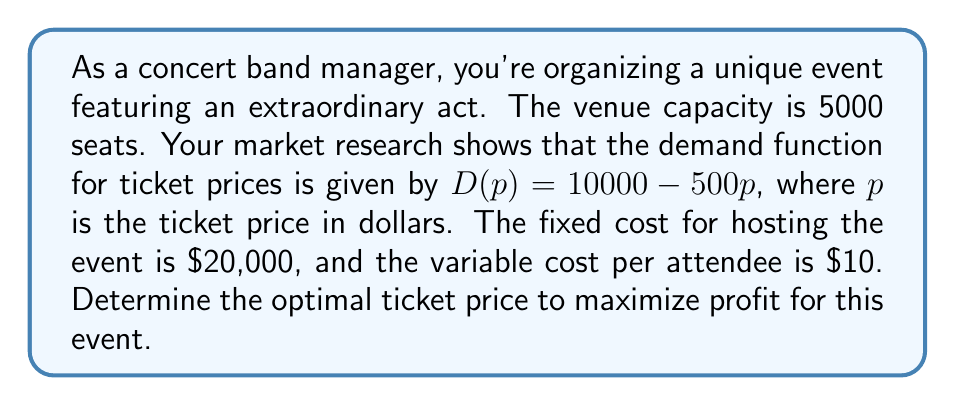What is the answer to this math problem? 1. Define the profit function:
   Profit = Revenue - Costs
   $\Pi(p) = pD(p) - (F + cD(p))$
   where $\Pi$ is profit, $p$ is price, $D(p)$ is demand, $F$ is fixed cost, and $c$ is variable cost per attendee.

2. Substitute the given values:
   $\Pi(p) = p(10000 - 500p) - (20000 + 10(10000 - 500p))$
   $\Pi(p) = 10000p - 500p^2 - 20000 - 100000 + 5000p$
   $\Pi(p) = -500p^2 + 15000p - 120000$

3. To find the maximum profit, differentiate $\Pi(p)$ with respect to $p$ and set it to zero:
   $\frac{d\Pi}{dp} = -1000p + 15000 = 0$

4. Solve for $p$:
   $-1000p = -15000$
   $p = 15$

5. Verify it's a maximum by checking the second derivative:
   $\frac{d^2\Pi}{dp^2} = -1000 < 0$, confirming a maximum.

6. Check if the optimal price satisfies the venue capacity constraint:
   $D(15) = 10000 - 500(15) = 2500$ seats, which is within the 5000-seat capacity.

Therefore, the optimal ticket price is $15.
Answer: $15 